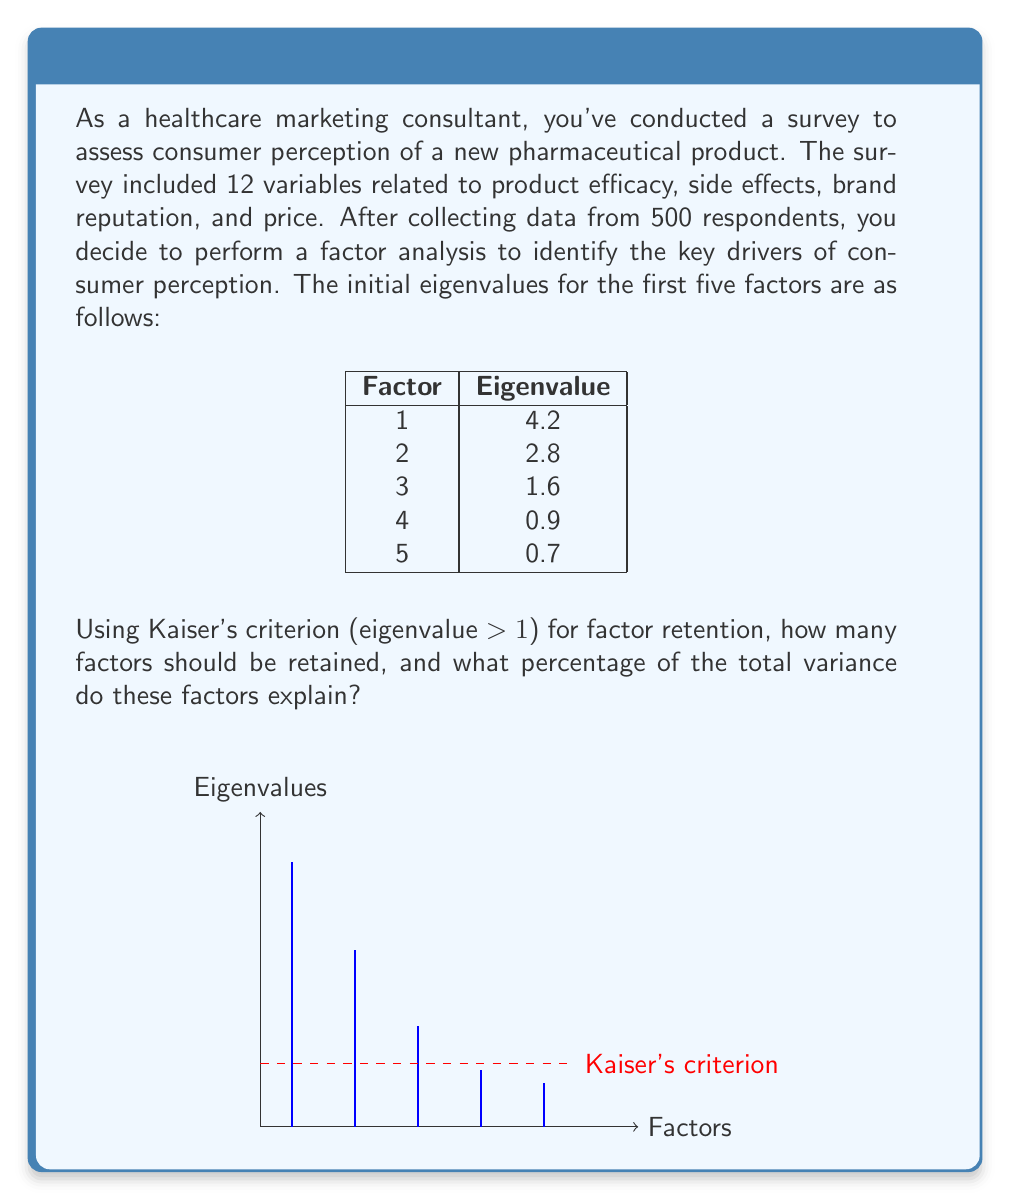What is the answer to this math problem? To solve this problem, we'll follow these steps:

1) Apply Kaiser's criterion: Retain factors with eigenvalues > 1
2) Count the number of factors meeting this criterion
3) Calculate the total variance
4) Calculate the variance explained by the retained factors
5) Compute the percentage of total variance explained

Step 1 & 2: Applying Kaiser's criterion and counting factors
Factors with eigenvalues > 1:
Factor 1: 4.2 > 1
Factor 2: 2.8 > 1
Factor 3: 1.6 > 1
Factor 4: 0.9 < 1
Factor 5: 0.7 < 1

Therefore, we should retain 3 factors.

Step 3: Calculate total variance
In factor analysis, the total variance is equal to the number of variables. Since we have 12 variables, the total variance is 12.

Step 4: Calculate variance explained by retained factors
Variance explained = Sum of eigenvalues of retained factors
$$ \text{Variance explained} = 4.2 + 2.8 + 1.6 = 8.6 $$

Step 5: Compute percentage of total variance explained
$$ \text{Percentage explained} = \frac{\text{Variance explained}}{\text{Total variance}} \times 100\% $$
$$ = \frac{8.6}{12} \times 100\% = 71.67\% $$

Therefore, the 3 retained factors explain 71.67% of the total variance.
Answer: 3 factors; 71.67% of total variance 